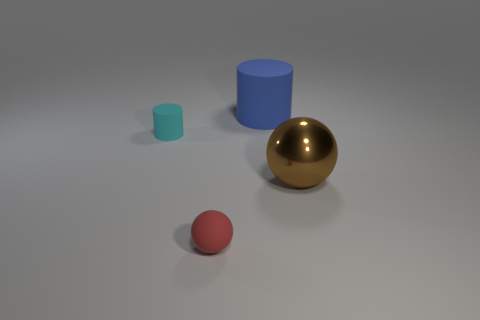Add 2 blue cylinders. How many objects exist? 6 Add 3 tiny rubber cylinders. How many tiny rubber cylinders are left? 4 Add 4 small gray balls. How many small gray balls exist? 4 Subtract 0 green balls. How many objects are left? 4 Subtract all spheres. Subtract all big brown objects. How many objects are left? 1 